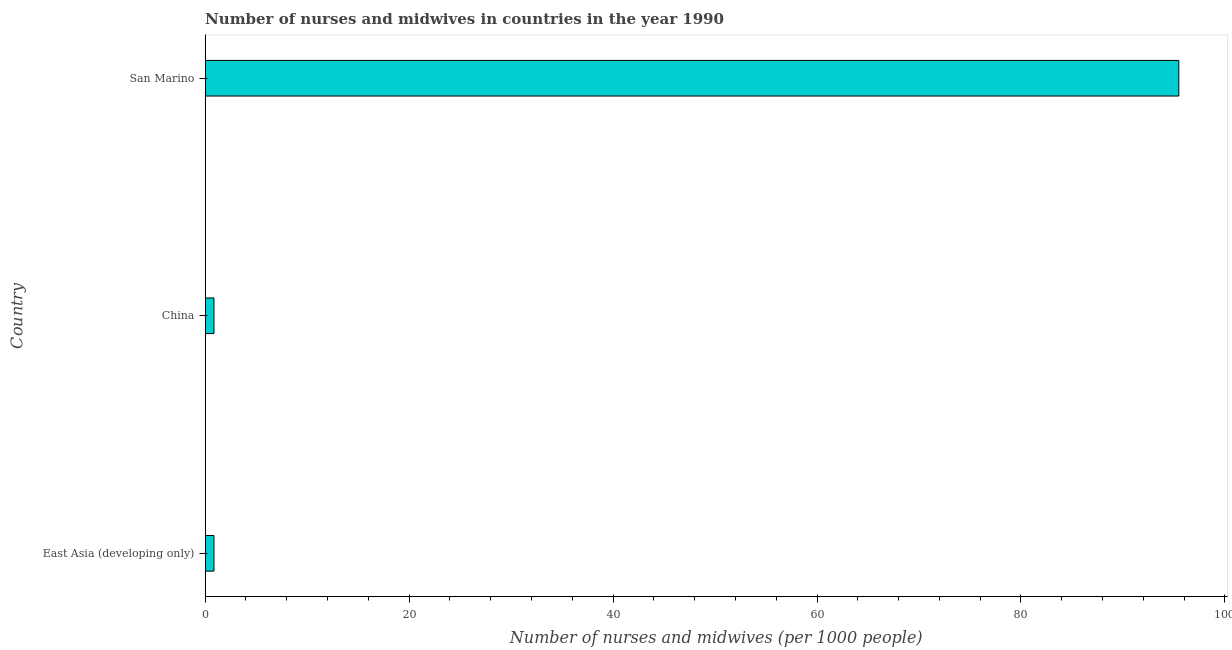What is the title of the graph?
Offer a terse response. Number of nurses and midwives in countries in the year 1990. What is the label or title of the X-axis?
Make the answer very short. Number of nurses and midwives (per 1000 people). What is the label or title of the Y-axis?
Give a very brief answer. Country. What is the number of nurses and midwives in China?
Provide a succinct answer. 0.86. Across all countries, what is the maximum number of nurses and midwives?
Provide a succinct answer. 95.48. Across all countries, what is the minimum number of nurses and midwives?
Give a very brief answer. 0.86. In which country was the number of nurses and midwives maximum?
Provide a short and direct response. San Marino. In which country was the number of nurses and midwives minimum?
Offer a terse response. East Asia (developing only). What is the sum of the number of nurses and midwives?
Your answer should be very brief. 97.2. What is the difference between the number of nurses and midwives in China and San Marino?
Offer a terse response. -94.62. What is the average number of nurses and midwives per country?
Your response must be concise. 32.4. What is the median number of nurses and midwives?
Keep it short and to the point. 0.86. In how many countries, is the number of nurses and midwives greater than 20 ?
Your response must be concise. 1. What is the ratio of the number of nurses and midwives in China to that in East Asia (developing only)?
Offer a terse response. 1. Is the number of nurses and midwives in China less than that in San Marino?
Provide a short and direct response. Yes. What is the difference between the highest and the second highest number of nurses and midwives?
Keep it short and to the point. 94.62. What is the difference between the highest and the lowest number of nurses and midwives?
Make the answer very short. 94.62. In how many countries, is the number of nurses and midwives greater than the average number of nurses and midwives taken over all countries?
Give a very brief answer. 1. Are all the bars in the graph horizontal?
Offer a very short reply. Yes. What is the difference between two consecutive major ticks on the X-axis?
Make the answer very short. 20. Are the values on the major ticks of X-axis written in scientific E-notation?
Make the answer very short. No. What is the Number of nurses and midwives (per 1000 people) of East Asia (developing only)?
Keep it short and to the point. 0.86. What is the Number of nurses and midwives (per 1000 people) in China?
Make the answer very short. 0.86. What is the Number of nurses and midwives (per 1000 people) of San Marino?
Provide a short and direct response. 95.48. What is the difference between the Number of nurses and midwives (per 1000 people) in East Asia (developing only) and China?
Keep it short and to the point. 0. What is the difference between the Number of nurses and midwives (per 1000 people) in East Asia (developing only) and San Marino?
Provide a succinct answer. -94.62. What is the difference between the Number of nurses and midwives (per 1000 people) in China and San Marino?
Provide a succinct answer. -94.62. What is the ratio of the Number of nurses and midwives (per 1000 people) in East Asia (developing only) to that in San Marino?
Your response must be concise. 0.01. What is the ratio of the Number of nurses and midwives (per 1000 people) in China to that in San Marino?
Your response must be concise. 0.01. 